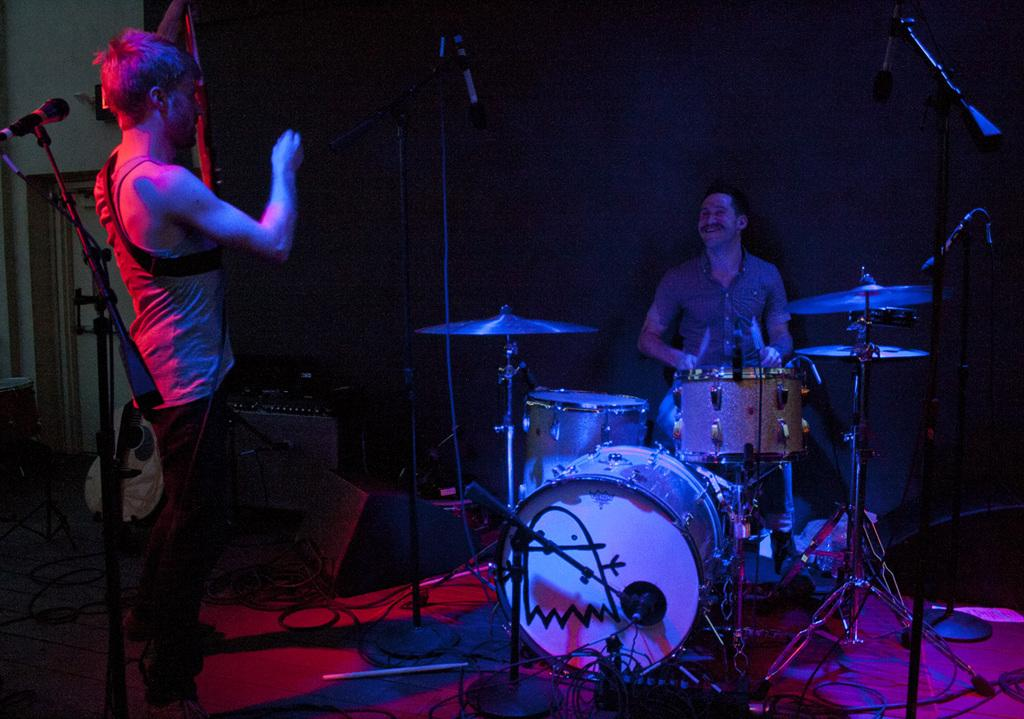How many people are in the image? There are two men in the image. What is one of the men holding? One man is holding sticks. What is the man holding sticks sitting in front of? The man holding sticks is sitting in front of drums. What is the other man positioned in front of? The other man is in front of a mic. What type of wool is being used to make the mic in the image? There is no wool present in the image, and the mic is not made of wool. 